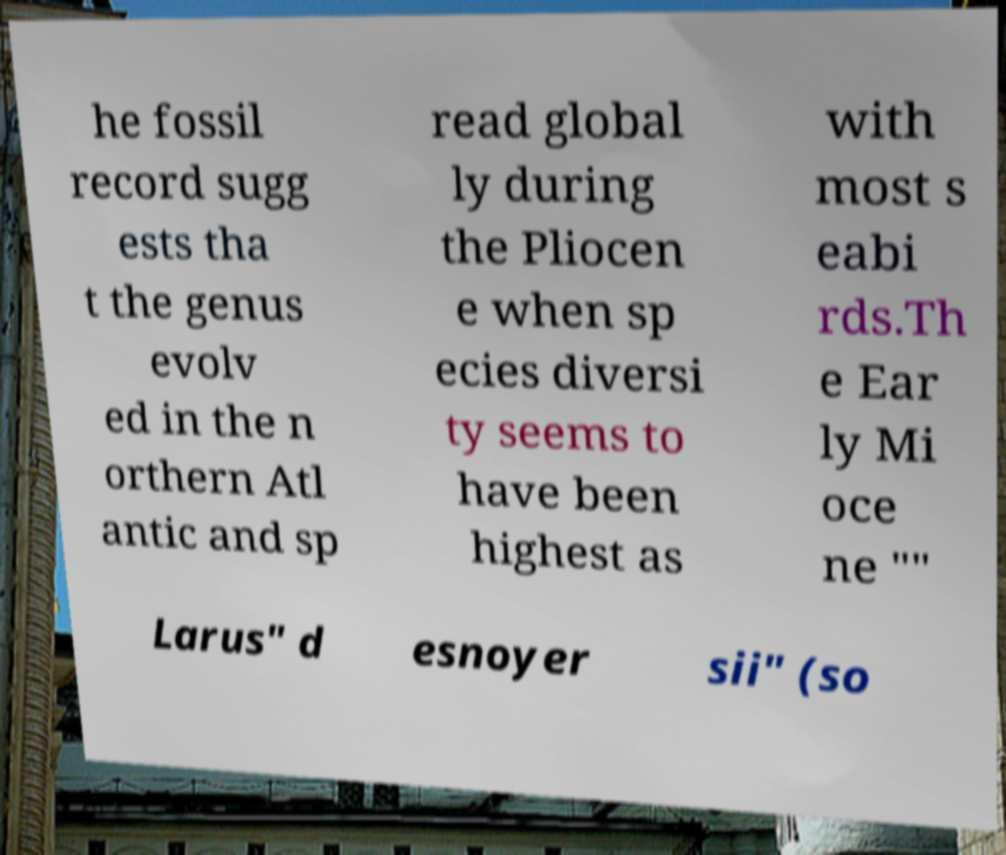There's text embedded in this image that I need extracted. Can you transcribe it verbatim? he fossil record sugg ests tha t the genus evolv ed in the n orthern Atl antic and sp read global ly during the Pliocen e when sp ecies diversi ty seems to have been highest as with most s eabi rds.Th e Ear ly Mi oce ne "" Larus" d esnoyer sii" (so 